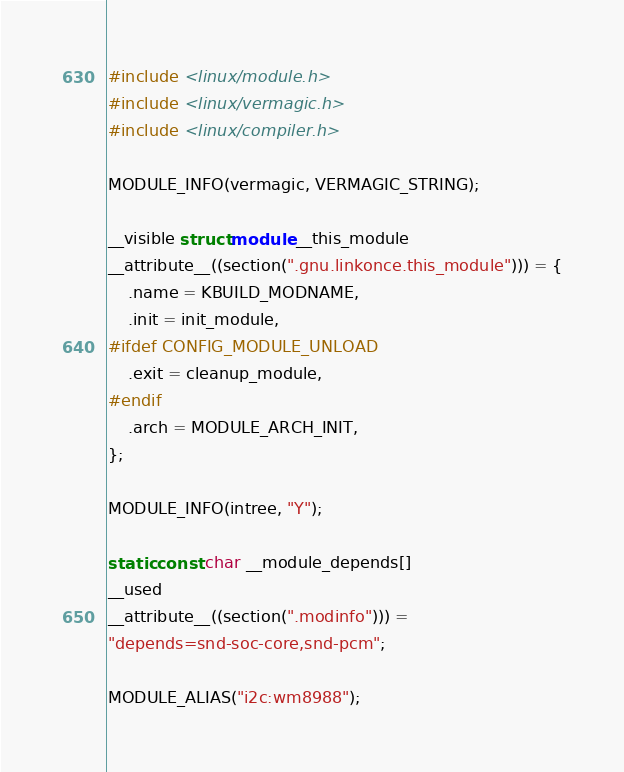Convert code to text. <code><loc_0><loc_0><loc_500><loc_500><_C_>#include <linux/module.h>
#include <linux/vermagic.h>
#include <linux/compiler.h>

MODULE_INFO(vermagic, VERMAGIC_STRING);

__visible struct module __this_module
__attribute__((section(".gnu.linkonce.this_module"))) = {
	.name = KBUILD_MODNAME,
	.init = init_module,
#ifdef CONFIG_MODULE_UNLOAD
	.exit = cleanup_module,
#endif
	.arch = MODULE_ARCH_INIT,
};

MODULE_INFO(intree, "Y");

static const char __module_depends[]
__used
__attribute__((section(".modinfo"))) =
"depends=snd-soc-core,snd-pcm";

MODULE_ALIAS("i2c:wm8988");
</code> 